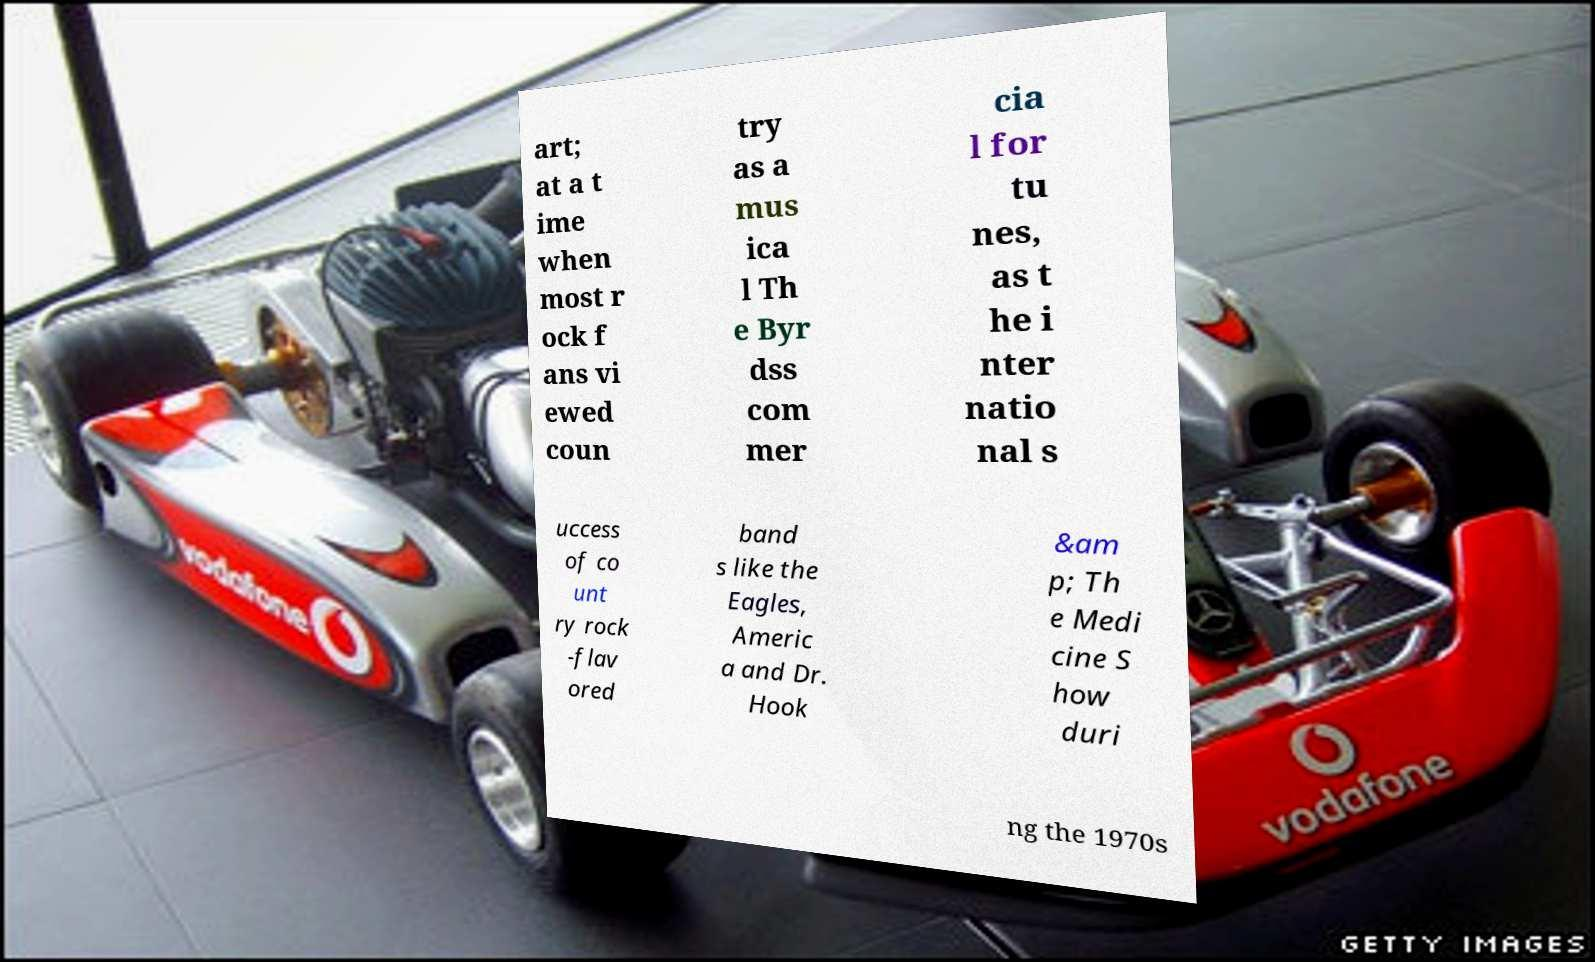Can you read and provide the text displayed in the image?This photo seems to have some interesting text. Can you extract and type it out for me? art; at a t ime when most r ock f ans vi ewed coun try as a mus ica l Th e Byr dss com mer cia l for tu nes, as t he i nter natio nal s uccess of co unt ry rock -flav ored band s like the Eagles, Americ a and Dr. Hook &am p; Th e Medi cine S how duri ng the 1970s 